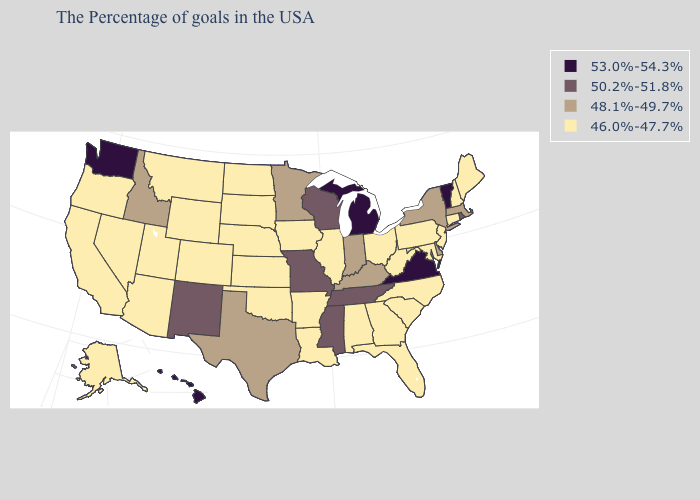What is the highest value in states that border Maryland?
Keep it brief. 53.0%-54.3%. Name the states that have a value in the range 53.0%-54.3%?
Give a very brief answer. Vermont, Virginia, Michigan, Washington, Hawaii. What is the value of Illinois?
Answer briefly. 46.0%-47.7%. What is the value of Louisiana?
Short answer required. 46.0%-47.7%. Does Minnesota have the lowest value in the MidWest?
Write a very short answer. No. Does New Jersey have the same value as South Dakota?
Quick response, please. Yes. Does Rhode Island have the highest value in the USA?
Concise answer only. No. Among the states that border Colorado , does New Mexico have the highest value?
Short answer required. Yes. Name the states that have a value in the range 53.0%-54.3%?
Give a very brief answer. Vermont, Virginia, Michigan, Washington, Hawaii. Name the states that have a value in the range 48.1%-49.7%?
Write a very short answer. Massachusetts, New York, Delaware, Kentucky, Indiana, Minnesota, Texas, Idaho. Which states have the lowest value in the Northeast?
Write a very short answer. Maine, New Hampshire, Connecticut, New Jersey, Pennsylvania. Does Arkansas have the lowest value in the USA?
Concise answer only. Yes. Name the states that have a value in the range 48.1%-49.7%?
Short answer required. Massachusetts, New York, Delaware, Kentucky, Indiana, Minnesota, Texas, Idaho. What is the value of Maryland?
Quick response, please. 46.0%-47.7%. 